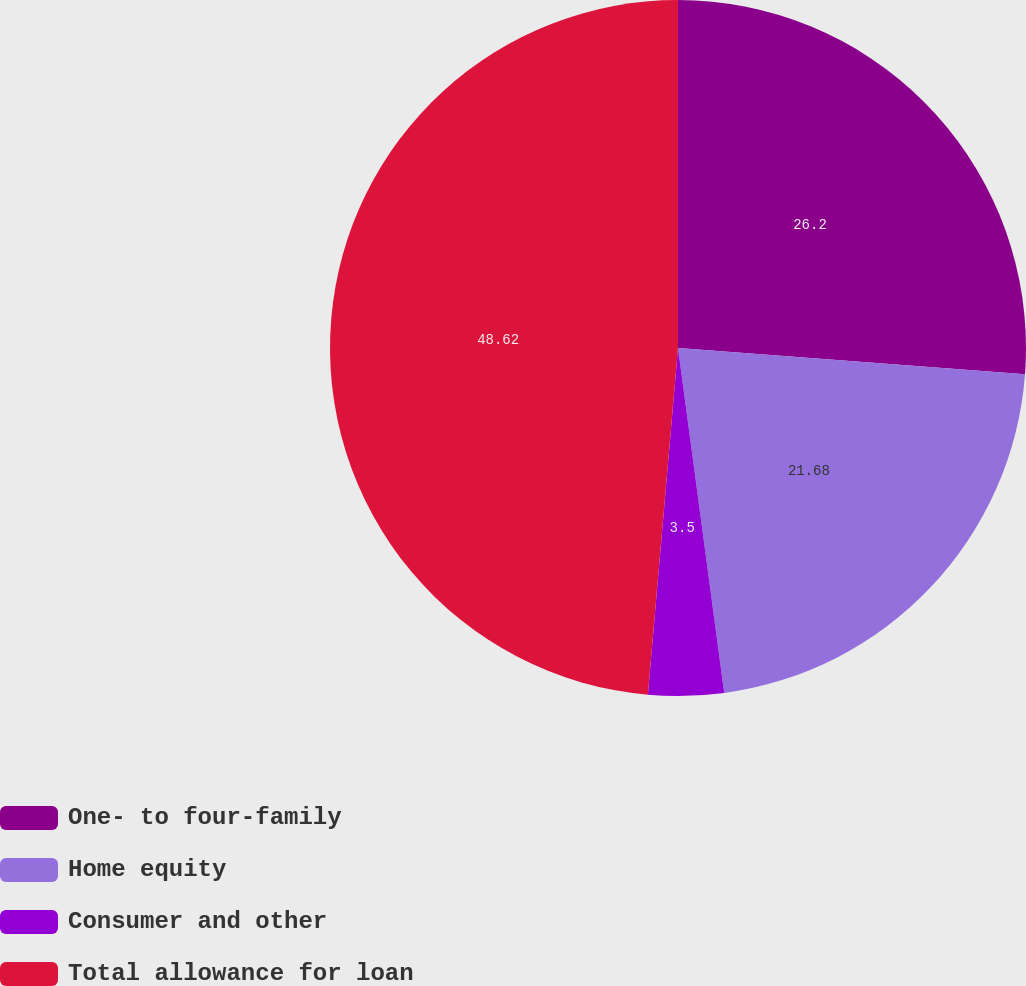<chart> <loc_0><loc_0><loc_500><loc_500><pie_chart><fcel>One- to four-family<fcel>Home equity<fcel>Consumer and other<fcel>Total allowance for loan<nl><fcel>26.2%<fcel>21.68%<fcel>3.5%<fcel>48.62%<nl></chart> 